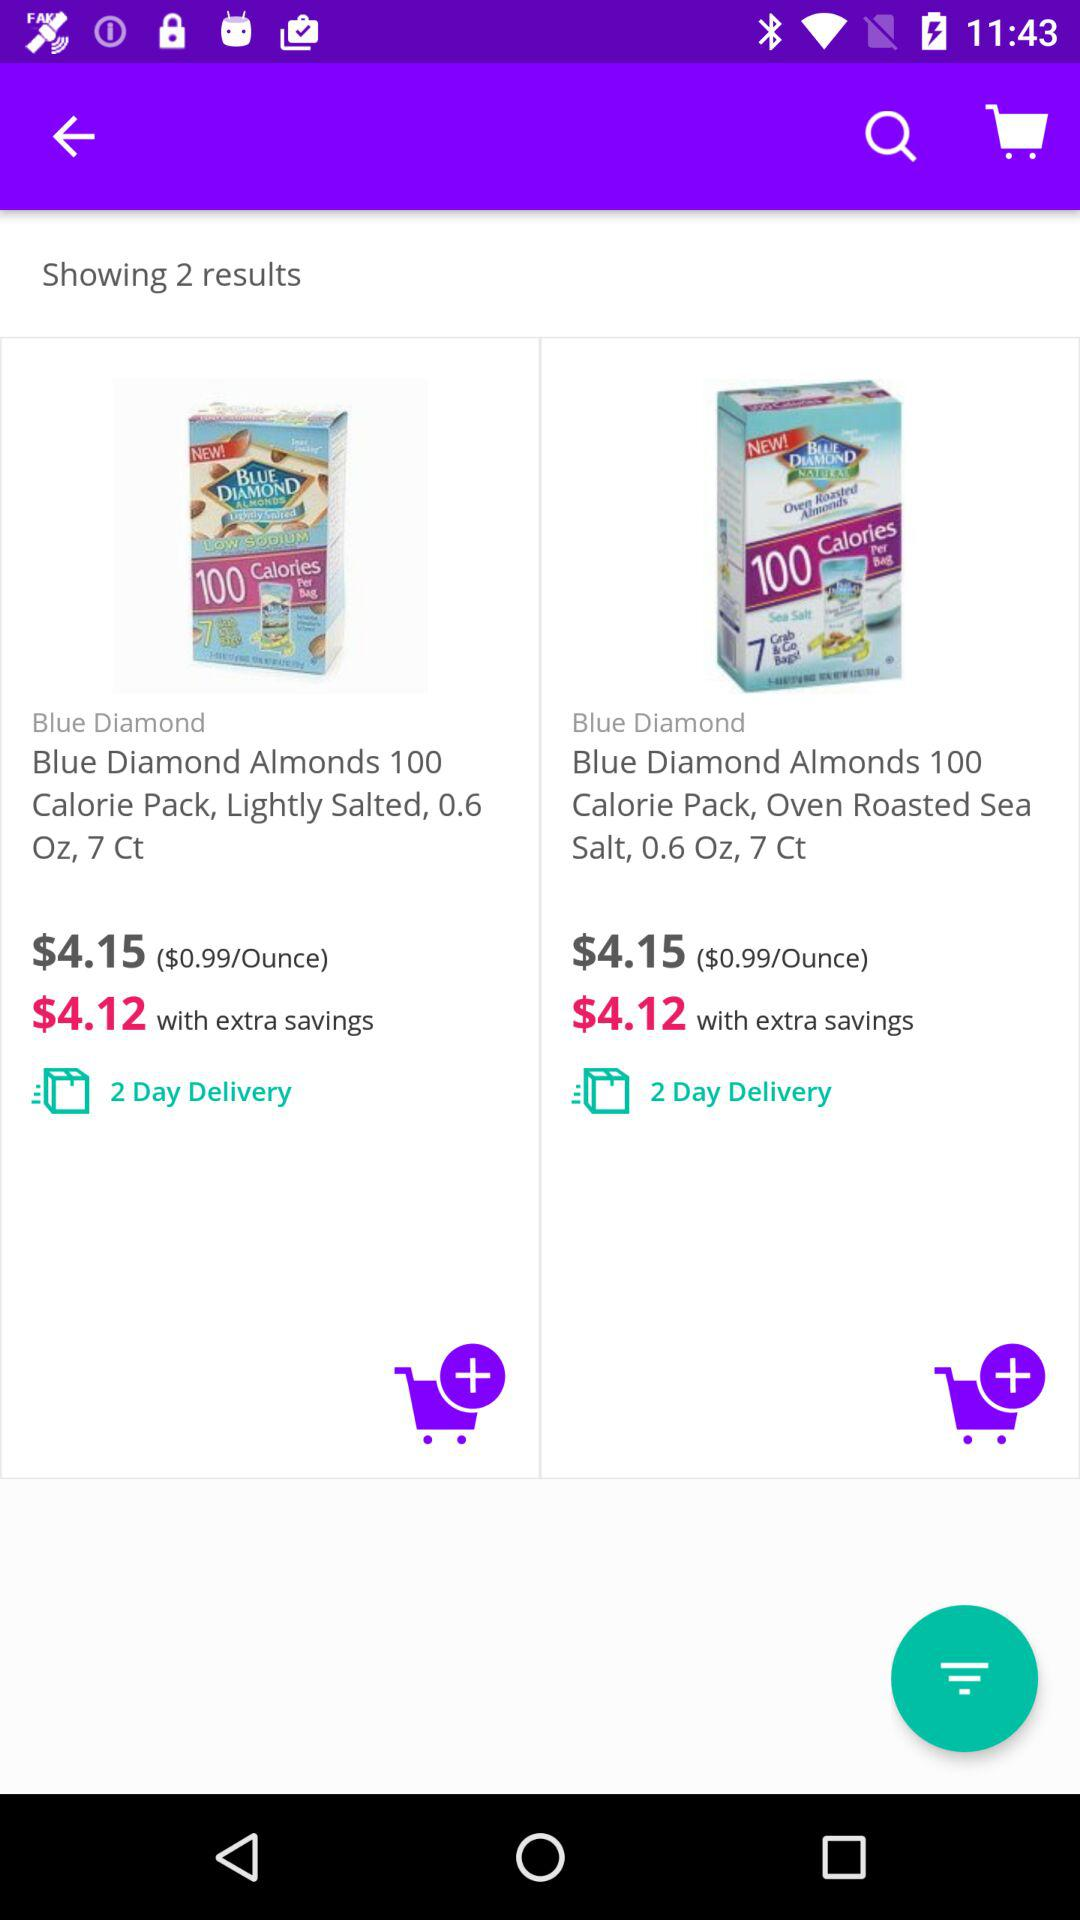How many items are available in the search results? 2 